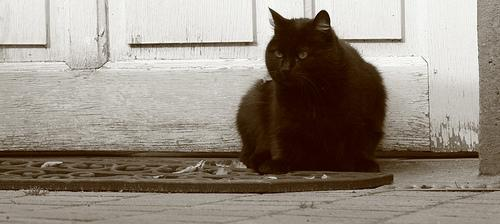Write a sentence about the focal object and its surroundings in the image. A black cat sits on a mat by a wooden door with chipped paint as grass grows nearby. Give a brief overview of what's happening in the image. The image features a black cat resting on a mat near the door, with the area around the door showing signs of wear and growth. Mention the main object in the image and what it is doing. A black cat is lying down on a door mat in front of a wooden door with chipped paint. In a few words, describe the primary elements seen in this image. Cat, mat, wooden door, paint chipping, and growing grass. Share a brief description of the main scene in the image. The photo shows a black cat lounging on a mat near a wooden door with chipped paint and grass growing nearby. Provide an overview of the primary action taking place in the image. In the image, a black cat is relaxing on a door mat, surrounded by a wooden door with chipping paint and growing grass. Explain the central object in the image and its surrounding context. There is a black cat sitting on a door mat in front of a wooden door with chipping paint; there's also grass and bricks on the ground nearby. Narrate the events depicted in the image and recall their surroundings. A black cat enjoys its time on a door mat, accompanied by a wooden door with chipping paint and some grass growing near bricks. Summarize the main activities happening in the image. A black cat is lying down on a mat by a wooden door, while paint chips and grass grow around the door. State the main character captured in the image and explain the situation. The image presents a black cat resting on a mat, with a wooden door in the background showing paint chipping and grass growing nearby. 